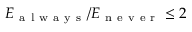<formula> <loc_0><loc_0><loc_500><loc_500>E _ { a l w a y s } / E _ { n e v e r } \leq 2</formula> 